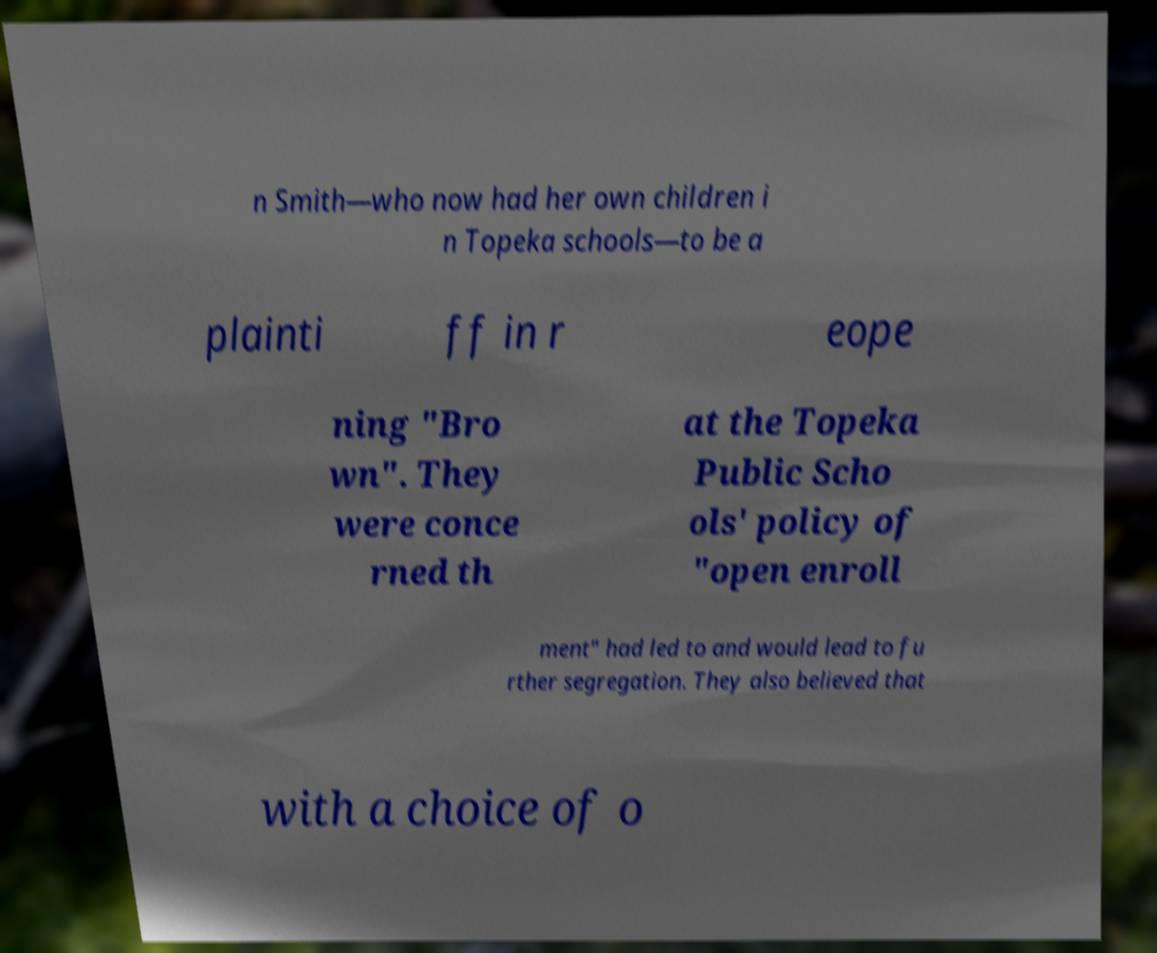Please identify and transcribe the text found in this image. n Smith—who now had her own children i n Topeka schools—to be a plainti ff in r eope ning "Bro wn". They were conce rned th at the Topeka Public Scho ols' policy of "open enroll ment" had led to and would lead to fu rther segregation. They also believed that with a choice of o 